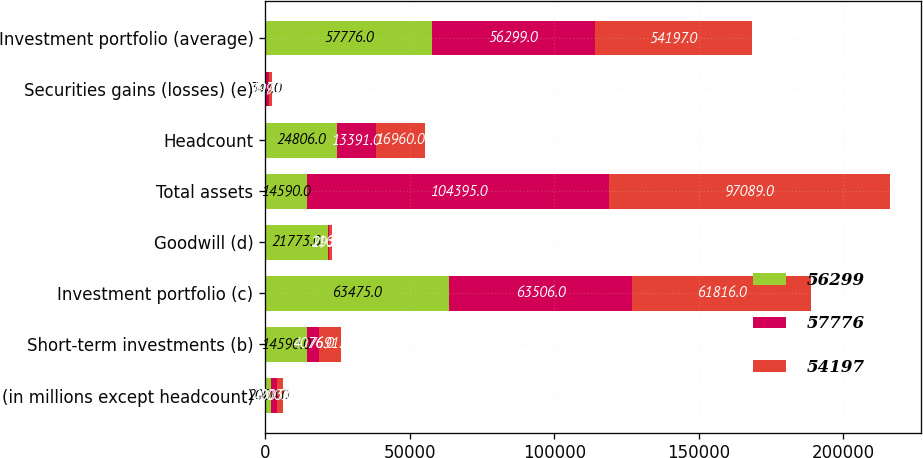Convert chart to OTSL. <chart><loc_0><loc_0><loc_500><loc_500><stacked_bar_chart><ecel><fcel>(in millions except headcount)<fcel>Short-term investments (b)<fcel>Investment portfolio (c)<fcel>Goodwill (d)<fcel>Total assets<fcel>Headcount<fcel>Securities gains (losses) (e)<fcel>Investment portfolio (average)<nl><fcel>56299<fcel>2004<fcel>14590<fcel>63475<fcel>21773<fcel>14590<fcel>24806<fcel>347<fcel>57776<nl><fcel>57776<fcel>2003<fcel>4076<fcel>63506<fcel>293<fcel>104395<fcel>13391<fcel>999<fcel>56299<nl><fcel>54197<fcel>2002<fcel>7691<fcel>61816<fcel>1166<fcel>97089<fcel>16960<fcel>1073<fcel>54197<nl></chart> 